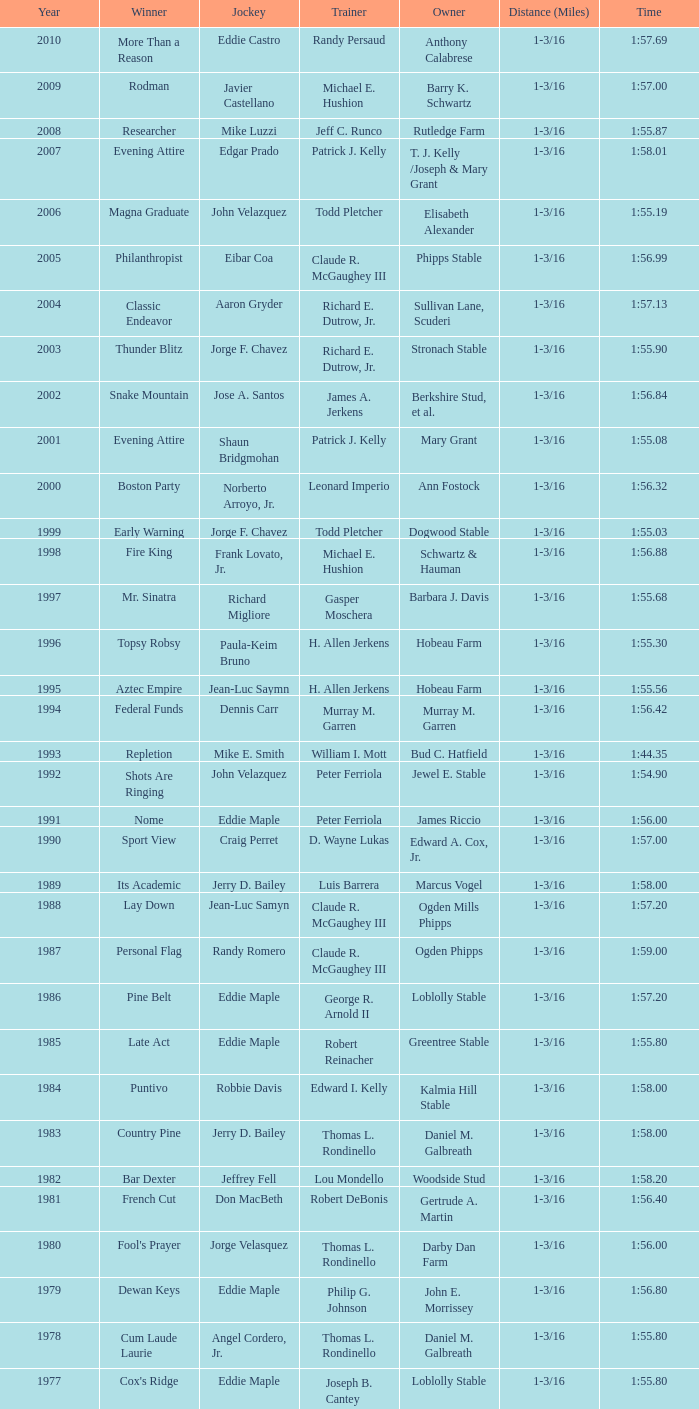Which jockey rode the victorious horse helioptic? Paul Miller. 